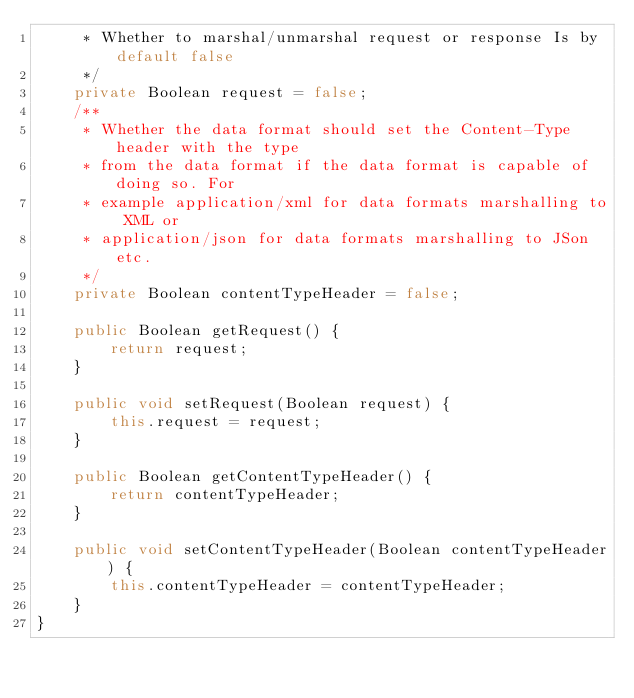<code> <loc_0><loc_0><loc_500><loc_500><_Java_>     * Whether to marshal/unmarshal request or response Is by default false
     */
    private Boolean request = false;
    /**
     * Whether the data format should set the Content-Type header with the type
     * from the data format if the data format is capable of doing so. For
     * example application/xml for data formats marshalling to XML or
     * application/json for data formats marshalling to JSon etc.
     */
    private Boolean contentTypeHeader = false;

    public Boolean getRequest() {
        return request;
    }

    public void setRequest(Boolean request) {
        this.request = request;
    }

    public Boolean getContentTypeHeader() {
        return contentTypeHeader;
    }

    public void setContentTypeHeader(Boolean contentTypeHeader) {
        this.contentTypeHeader = contentTypeHeader;
    }
}</code> 